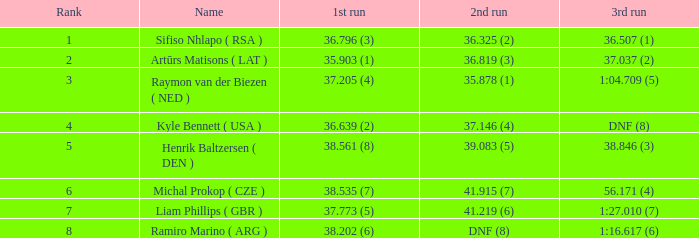In which 3rd run does the rank of 1st place occur? 36.507 (1). 